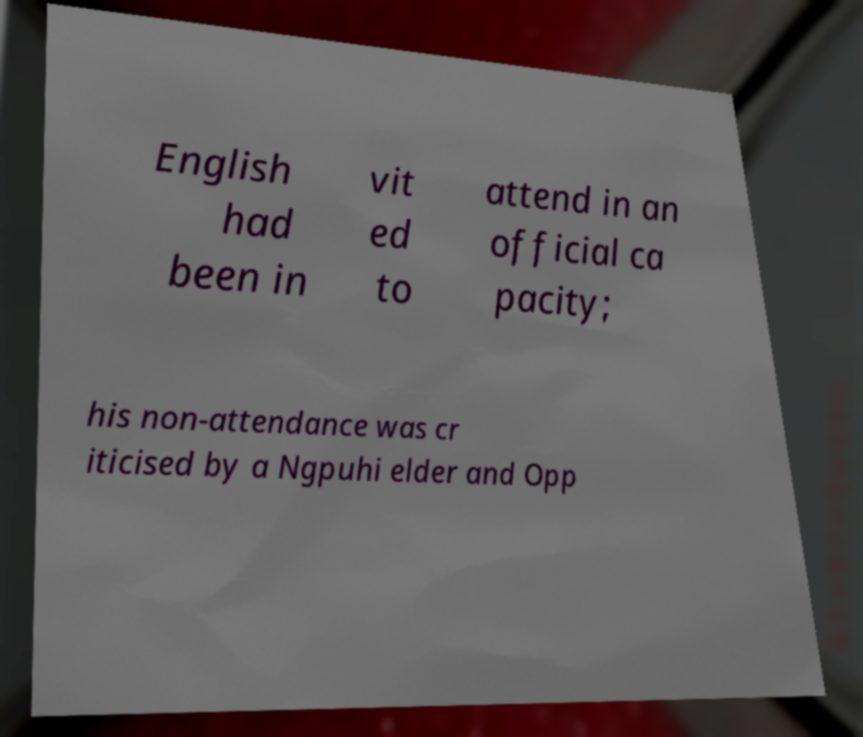I need the written content from this picture converted into text. Can you do that? English had been in vit ed to attend in an official ca pacity; his non-attendance was cr iticised by a Ngpuhi elder and Opp 